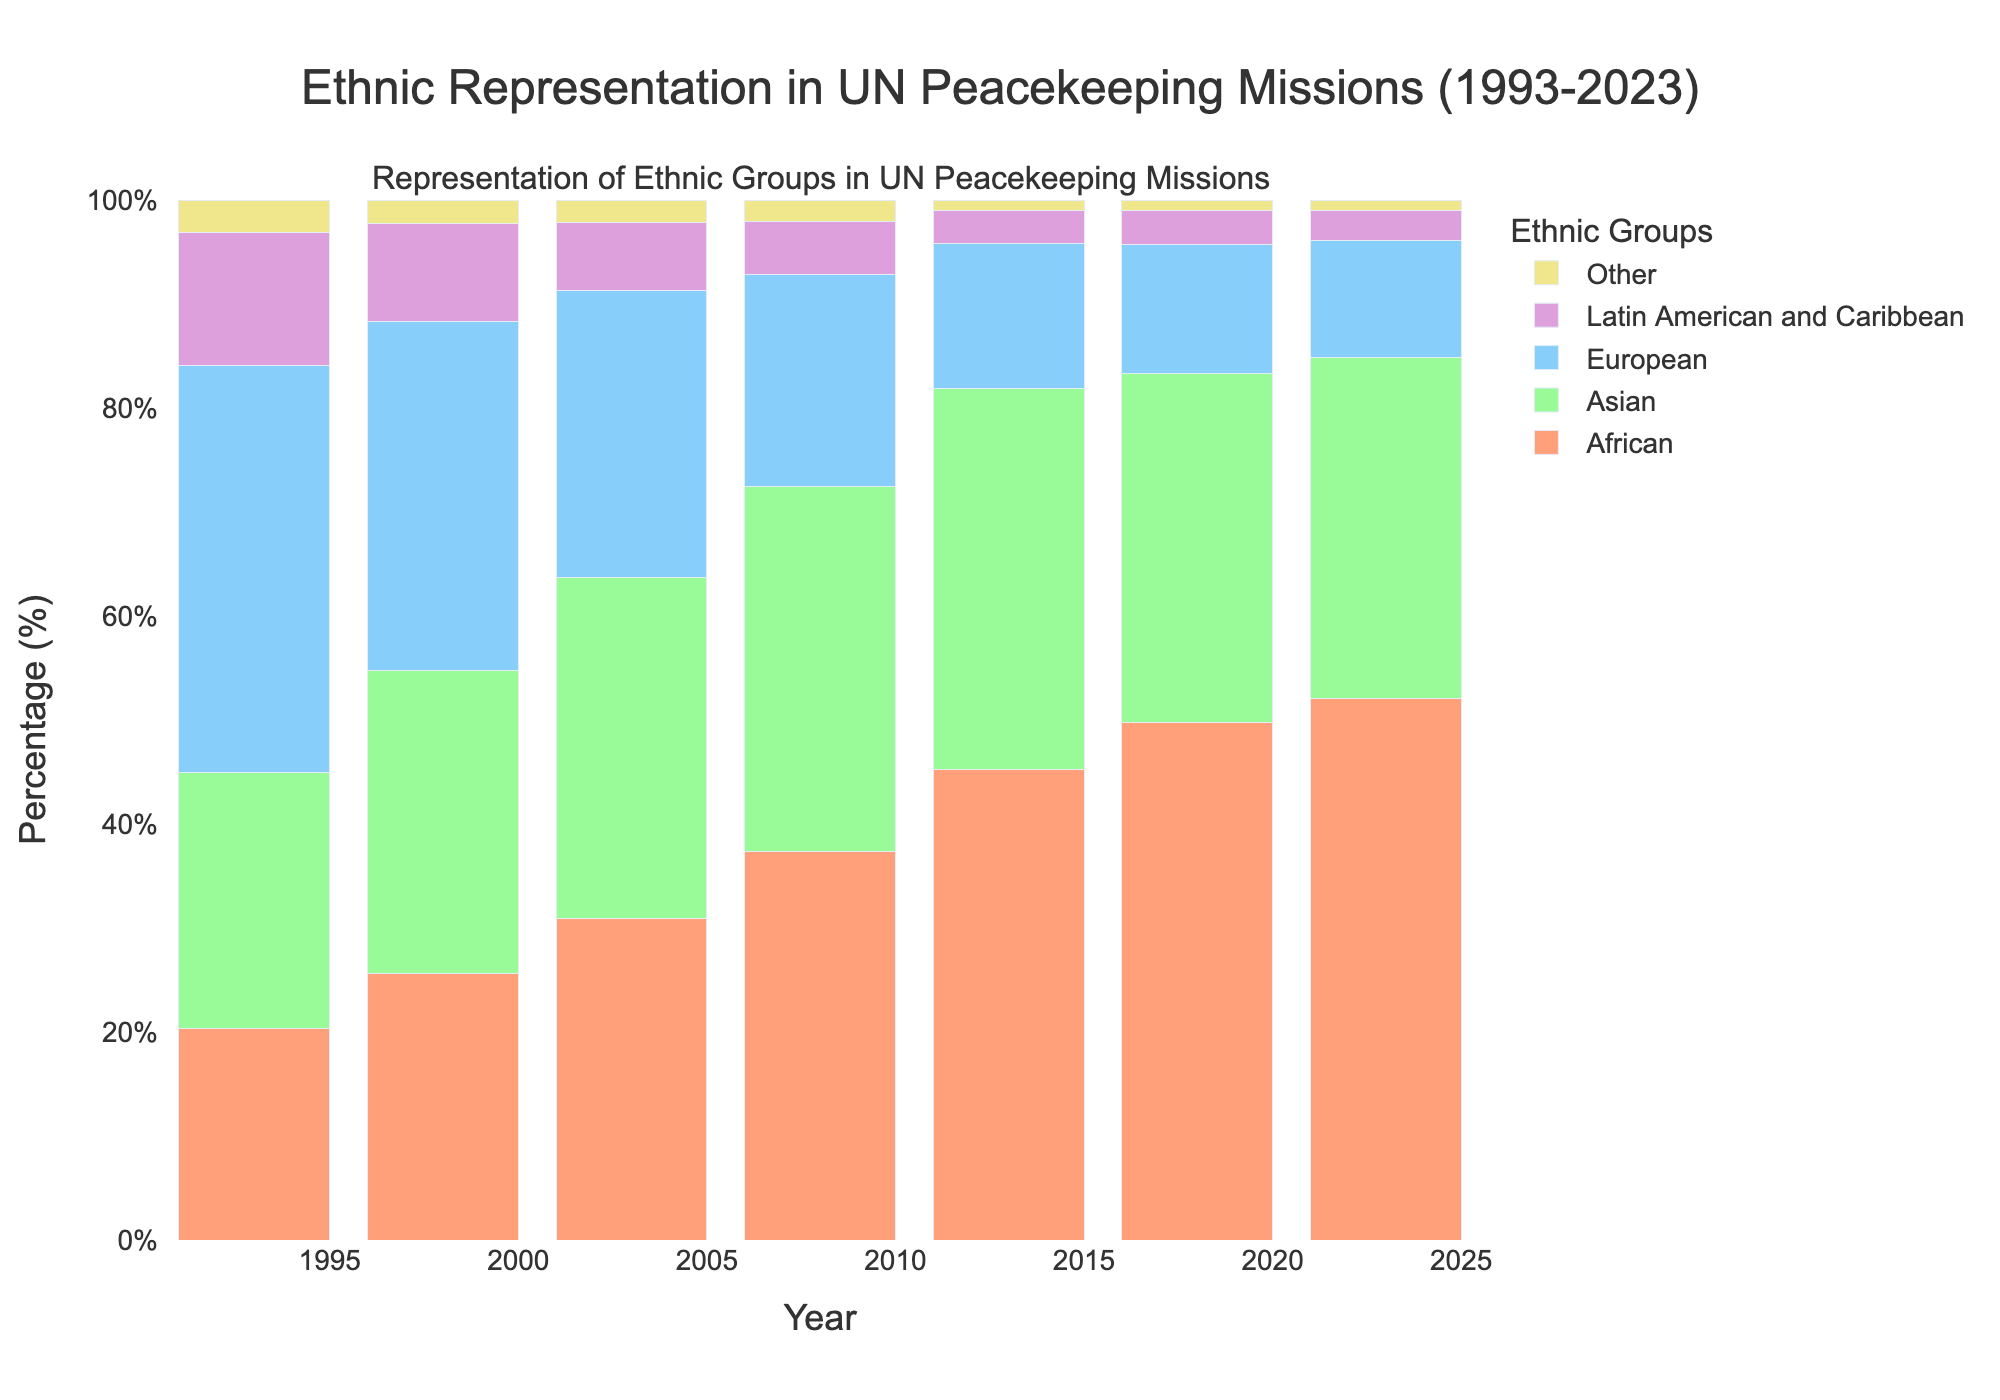What is the overall trend in the representation of African peacekeepers from 1993 to 2023? The bar for African peacekeepers shows a consistent upward trend, starting from 20.3% in 1993 and steadily increasing to 52.1% in 2023.
Answer: Increasing Which ethnic group had the highest representation in 1993? In 1993, the bar representing European peacekeepers is the tallest among all groups at 39.1%.
Answer: European How did the representation of European peacekeepers change from 1993 to 2023? The bar for European peacekeepers starts at 39.1% in 1993 and drops consistently each year, reaching 11.2% in 2023.
Answer: Decreasing In which year did African peacekeepers surpass Asian peacekeepers in their representation? The bars for African and Asian peacekeepers are compared year by year, and in 2008, African (37.4%) surpasses Asian (35.1%).
Answer: 2008 What is the combined representation percentage of all ethnic groups in 2013? In 2013, adding the percentages of African (45.2%), Asian (36.7%), European (13.9%), Latin American and Caribbean (3.2%), and Other (1.0%) yields 100%.
Answer: 100% Between 2013 and 2018, did the representation of Latin American and Caribbean peacekeepers increase or decrease? Comparing the bars for Latin American and Caribbean peacekeepers in 2013 (3.2%) and 2018 (3.3%), it is slightly increasing.
Answer: Increase Which ethnic group showed the least change in their representation from 1993 to 2023? Comparing the heights of the bars for each year, the "Other" category shows minimal change from 3.1% in 1993 to 1.0% in 2023.
Answer: Other By how much did the percentage of African peacekeepers increase between 1993 and 2023? Subtracting the percentage of African peacekeepers in 1993 (20.3%) from that in 2023 (52.1%) results in an increase of 31.8%.
Answer: 31.8% What visual change occurred in the representation of Latin American and Caribbean peacekeepers from 1993 to 2023? The bar for Latin American and Caribbean peacekeepers decreases in height, going from 12.8% in 1993 to 2.9% in 2023.
Answer: Decreased in height Which ethnic group had almost stable representation of around 1% from 2013 to 2023? The bars for the "Other" category consistently hover around 1.0% from 2013 to 2023.
Answer: Other 